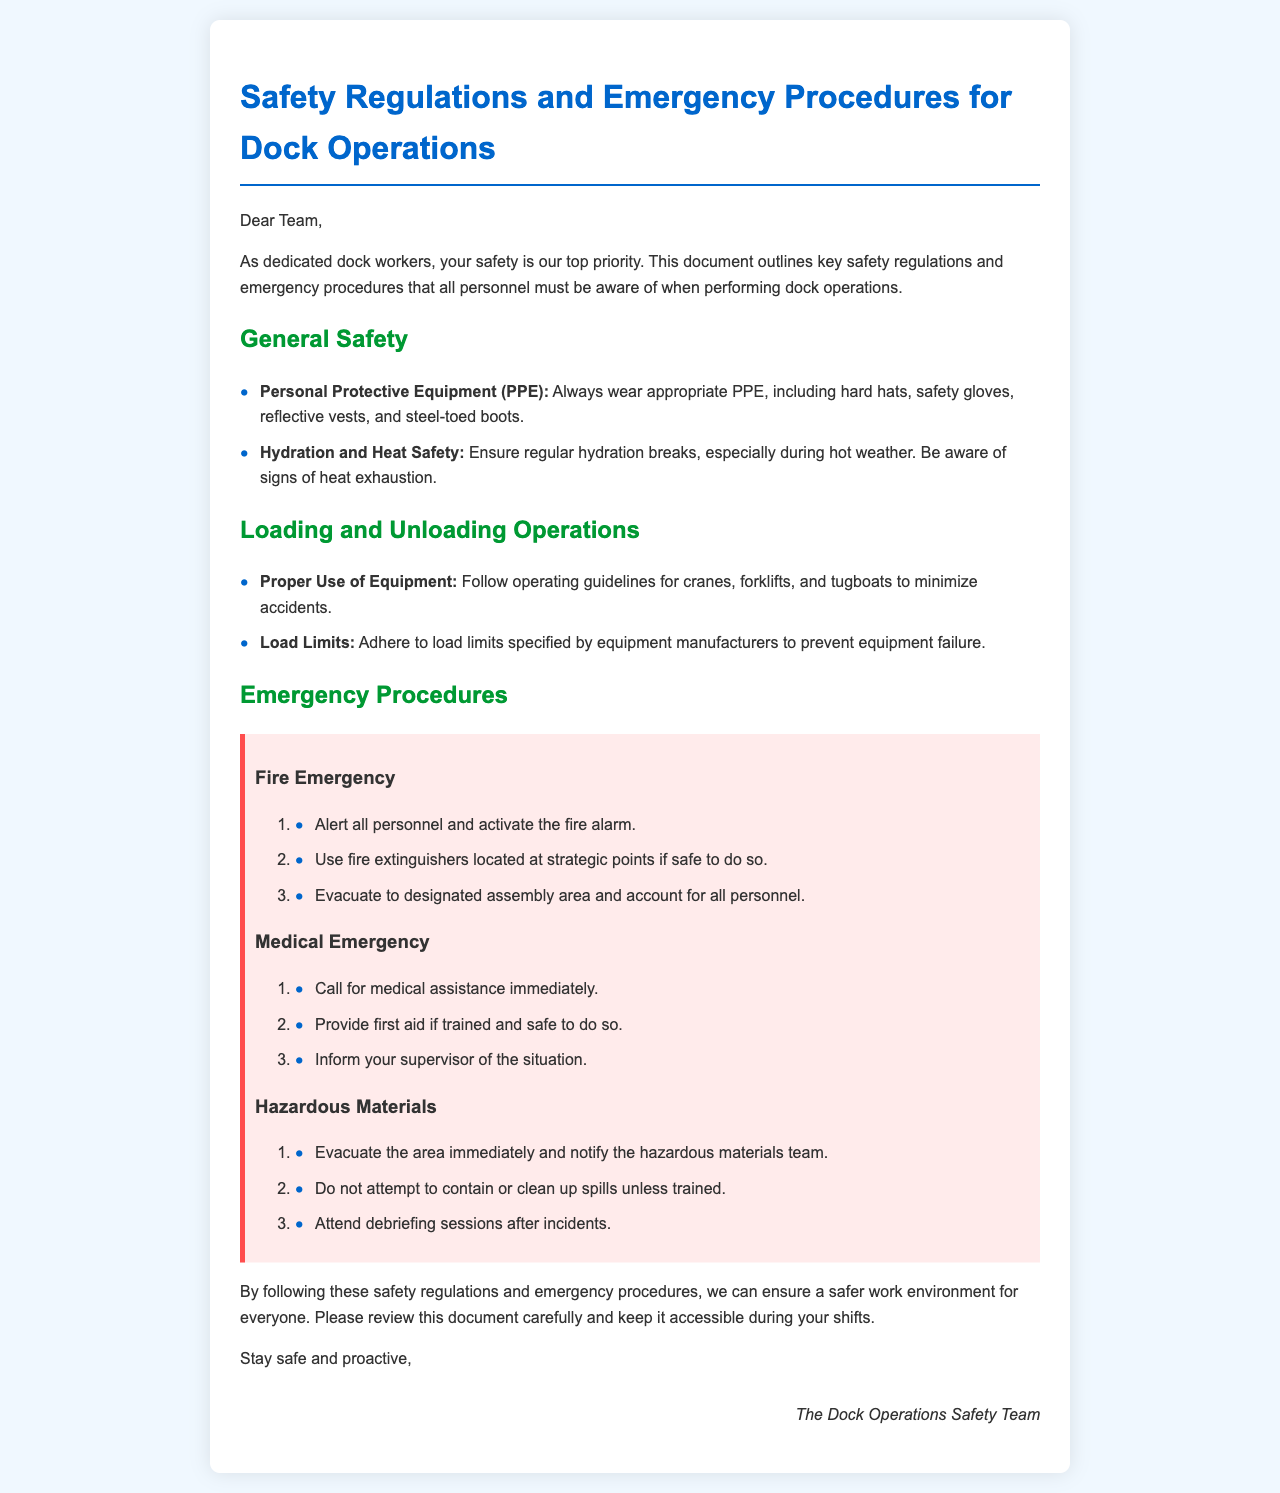what is the main purpose of the document? The main purpose of the document is to outline key safety regulations and emergency procedures for dock operations.
Answer: safety regulations and emergency procedures how many items are listed under General Safety? There are two items listed under General Safety in the document.
Answer: 2 what should you wear as part of your PPE? The document specifies that you should wear hard hats, safety gloves, reflective vests, and steel-toed boots.
Answer: hard hats, safety gloves, reflective vests, steel-toed boots what is the first step in a fire emergency? The first step in a fire emergency is to alert all personnel and activate the fire alarm.
Answer: alert all personnel and activate the fire alarm who should be informed during a medical emergency? You should inform your supervisor of the situation during a medical emergency.
Answer: your supervisor what should you do if hazardous materials spill? If hazardous materials spill, you should evacuate the area and notify the hazardous materials team.
Answer: evacuate the area and notify the hazardous materials team what color is the emergency section background? The background color of the emergency section is light red (ffebeb).
Answer: light red what should you do regarding hydration and heat safety? You should ensure regular hydration breaks and be aware of signs of heat exhaustion.
Answer: ensure regular hydration breaks how should you account for personnel after a fire emergency? You should evacuate to the designated assembly area and account for all personnel.
Answer: evacuate to designated assembly area and account for all personnel 